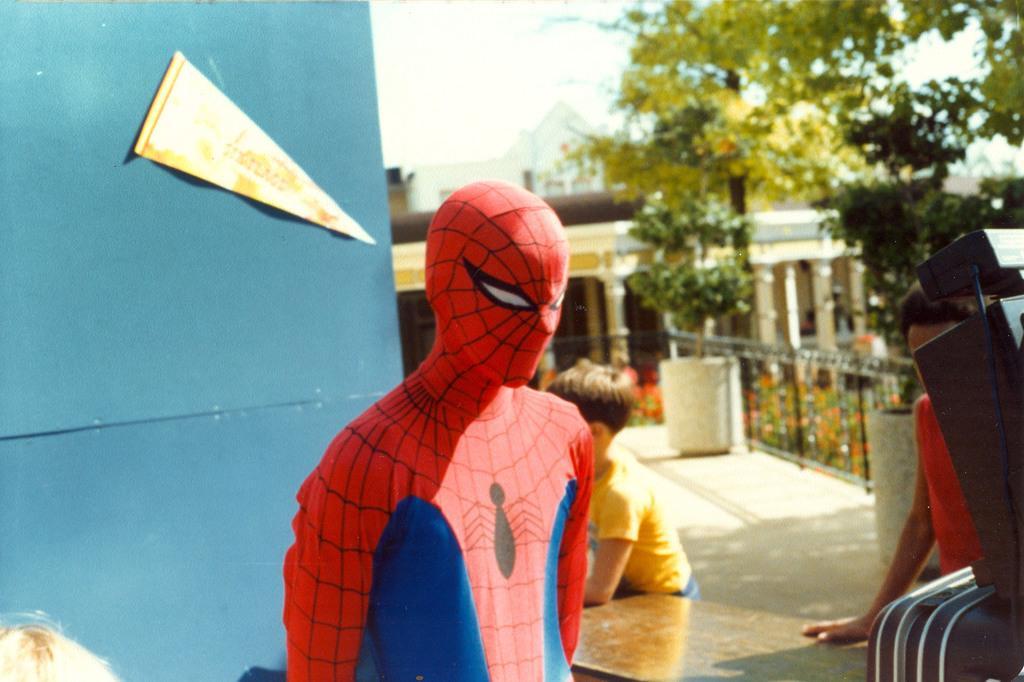Describe this image in one or two sentences. Here I can see a person wearing a costume. At the back of him there are two more persons. At the bottom there is a table. On the right side there is an object. On the left side there is a board. In the background there are many trees and buildings. At the top of the image I can see the sky. 